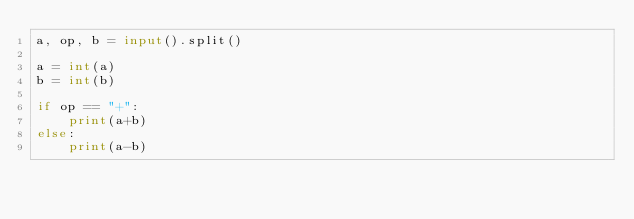Convert code to text. <code><loc_0><loc_0><loc_500><loc_500><_Python_>a, op, b = input().split()

a = int(a)
b = int(b)

if op == "+":
    print(a+b)
else:
    print(a-b)</code> 